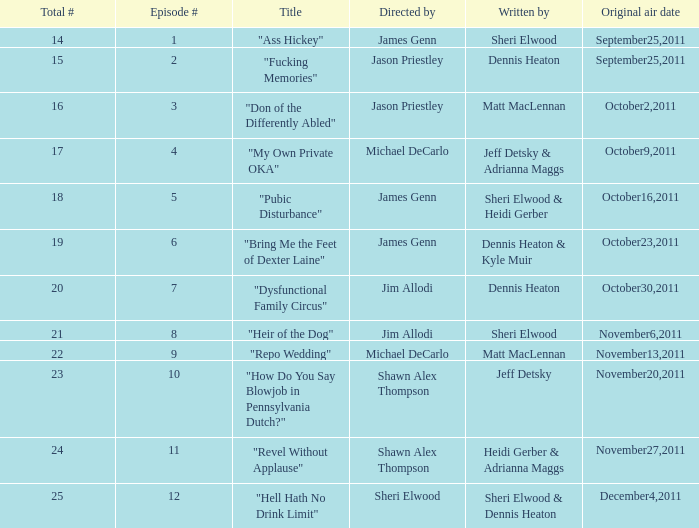What is the count of unique episode numbers for the episode authored by sheri elwood and directed by jim allodi? 1.0. Could you parse the entire table as a dict? {'header': ['Total #', 'Episode #', 'Title', 'Directed by', 'Written by', 'Original air date'], 'rows': [['14', '1', '"Ass Hickey"', 'James Genn', 'Sheri Elwood', 'September25,2011'], ['15', '2', '"Fucking Memories"', 'Jason Priestley', 'Dennis Heaton', 'September25,2011'], ['16', '3', '"Don of the Differently Abled"', 'Jason Priestley', 'Matt MacLennan', 'October2,2011'], ['17', '4', '"My Own Private OKA"', 'Michael DeCarlo', 'Jeff Detsky & Adrianna Maggs', 'October9,2011'], ['18', '5', '"Pubic Disturbance"', 'James Genn', 'Sheri Elwood & Heidi Gerber', 'October16,2011'], ['19', '6', '"Bring Me the Feet of Dexter Laine"', 'James Genn', 'Dennis Heaton & Kyle Muir', 'October23,2011'], ['20', '7', '"Dysfunctional Family Circus"', 'Jim Allodi', 'Dennis Heaton', 'October30,2011'], ['21', '8', '"Heir of the Dog"', 'Jim Allodi', 'Sheri Elwood', 'November6,2011'], ['22', '9', '"Repo Wedding"', 'Michael DeCarlo', 'Matt MacLennan', 'November13,2011'], ['23', '10', '"How Do You Say Blowjob in Pennsylvania Dutch?"', 'Shawn Alex Thompson', 'Jeff Detsky', 'November20,2011'], ['24', '11', '"Revel Without Applause"', 'Shawn Alex Thompson', 'Heidi Gerber & Adrianna Maggs', 'November27,2011'], ['25', '12', '"Hell Hath No Drink Limit"', 'Sheri Elwood', 'Sheri Elwood & Dennis Heaton', 'December4,2011']]} 